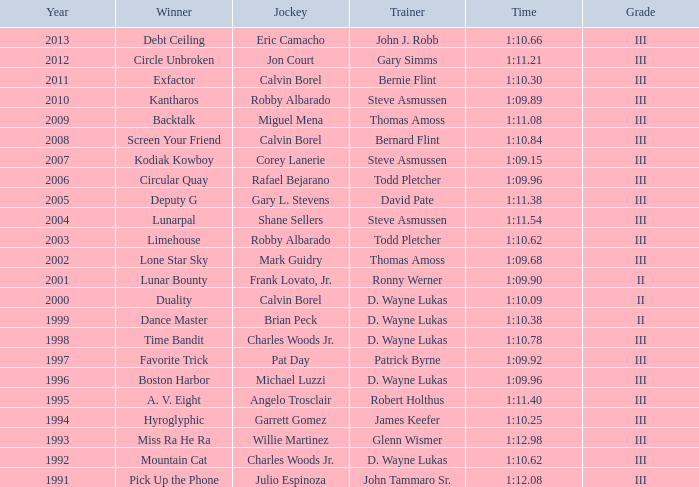Which trainer had a time of 1:10.09 with a year less than 2009? D. Wayne Lukas. 